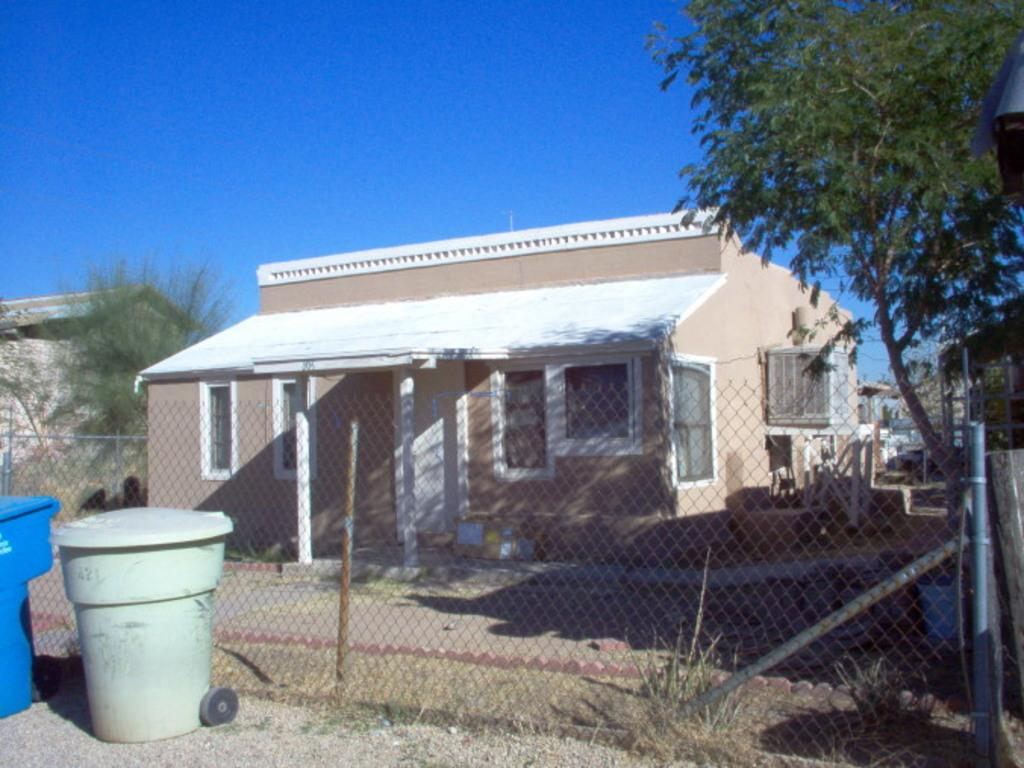What type of containers are on the ground in the image? There are bins on the ground in the image. What type of barrier can be seen in the image? There is a fence in the image. What type of vegetation is present in the image? There are trees in the image. What type of structures are visible in the image? There are houses with windows in the image. What type of objects can be seen in the image? There are objects in the image. What is visible in the background of the image? The sky is visible in the background of the image. Where is the field located in the image? There is no field present in the image. What type of root can be seen growing in the image? There are no roots visible in the image. 